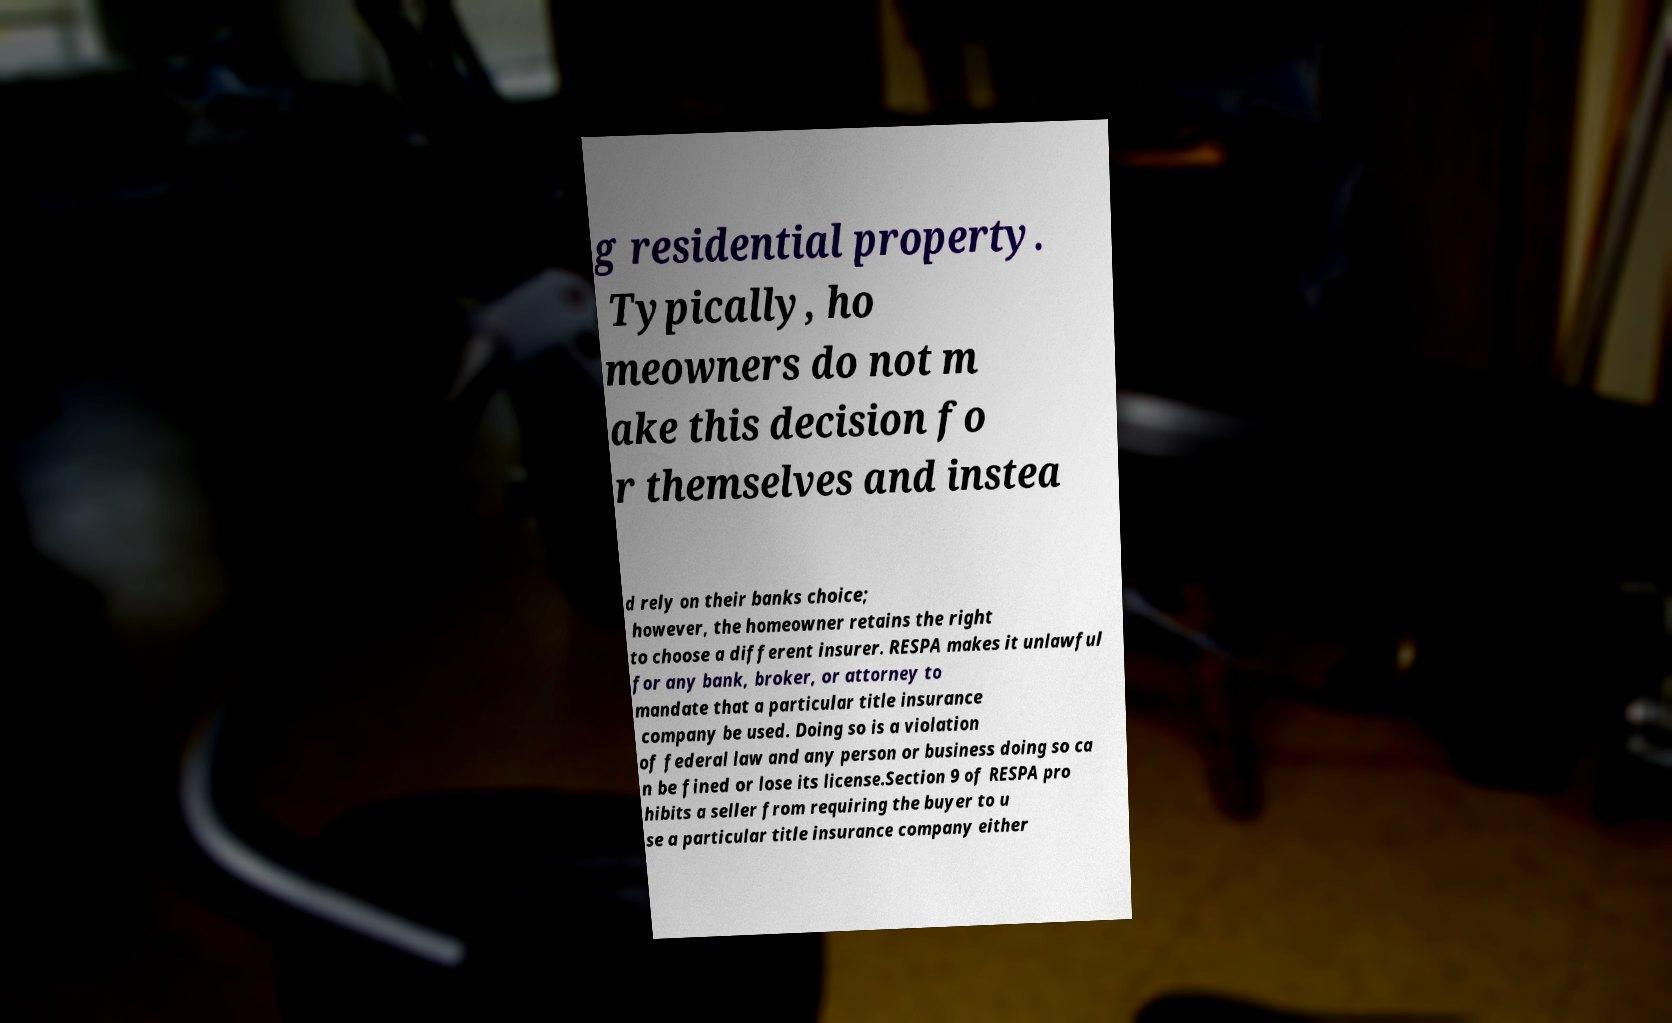For documentation purposes, I need the text within this image transcribed. Could you provide that? g residential property. Typically, ho meowners do not m ake this decision fo r themselves and instea d rely on their banks choice; however, the homeowner retains the right to choose a different insurer. RESPA makes it unlawful for any bank, broker, or attorney to mandate that a particular title insurance company be used. Doing so is a violation of federal law and any person or business doing so ca n be fined or lose its license.Section 9 of RESPA pro hibits a seller from requiring the buyer to u se a particular title insurance company either 